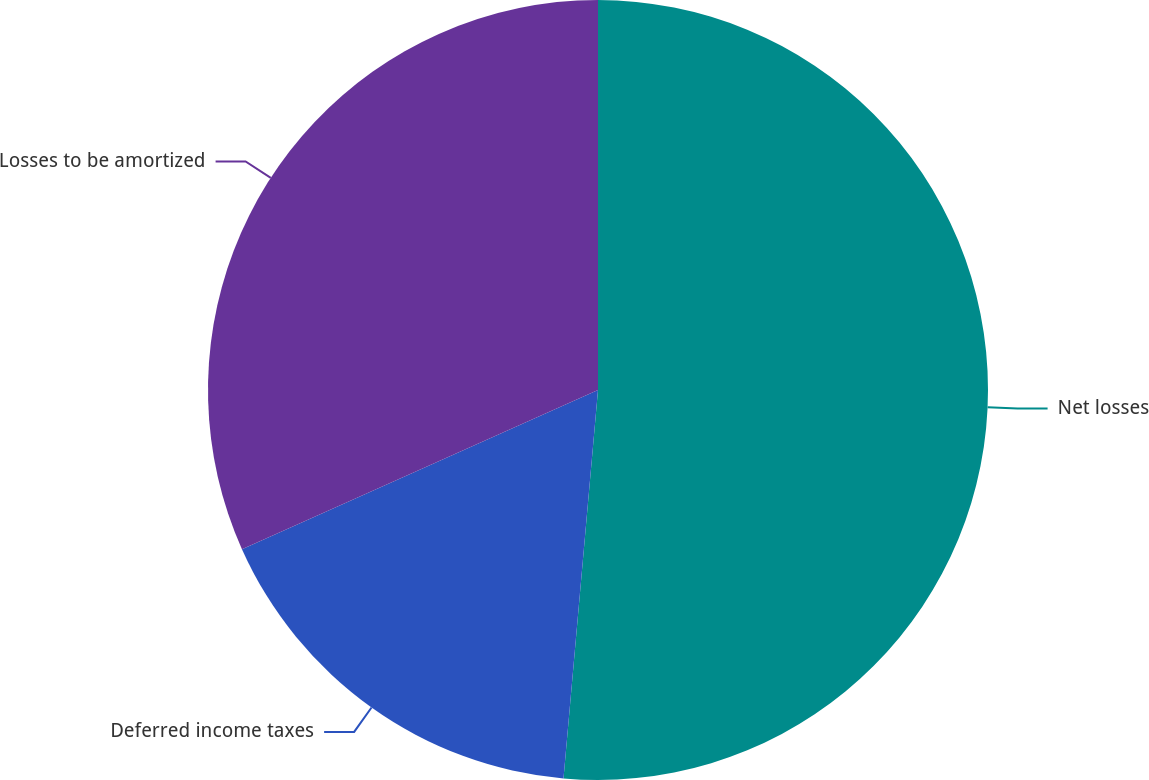<chart> <loc_0><loc_0><loc_500><loc_500><pie_chart><fcel>Net losses<fcel>Deferred income taxes<fcel>Losses to be amortized<nl><fcel>51.41%<fcel>16.9%<fcel>31.69%<nl></chart> 